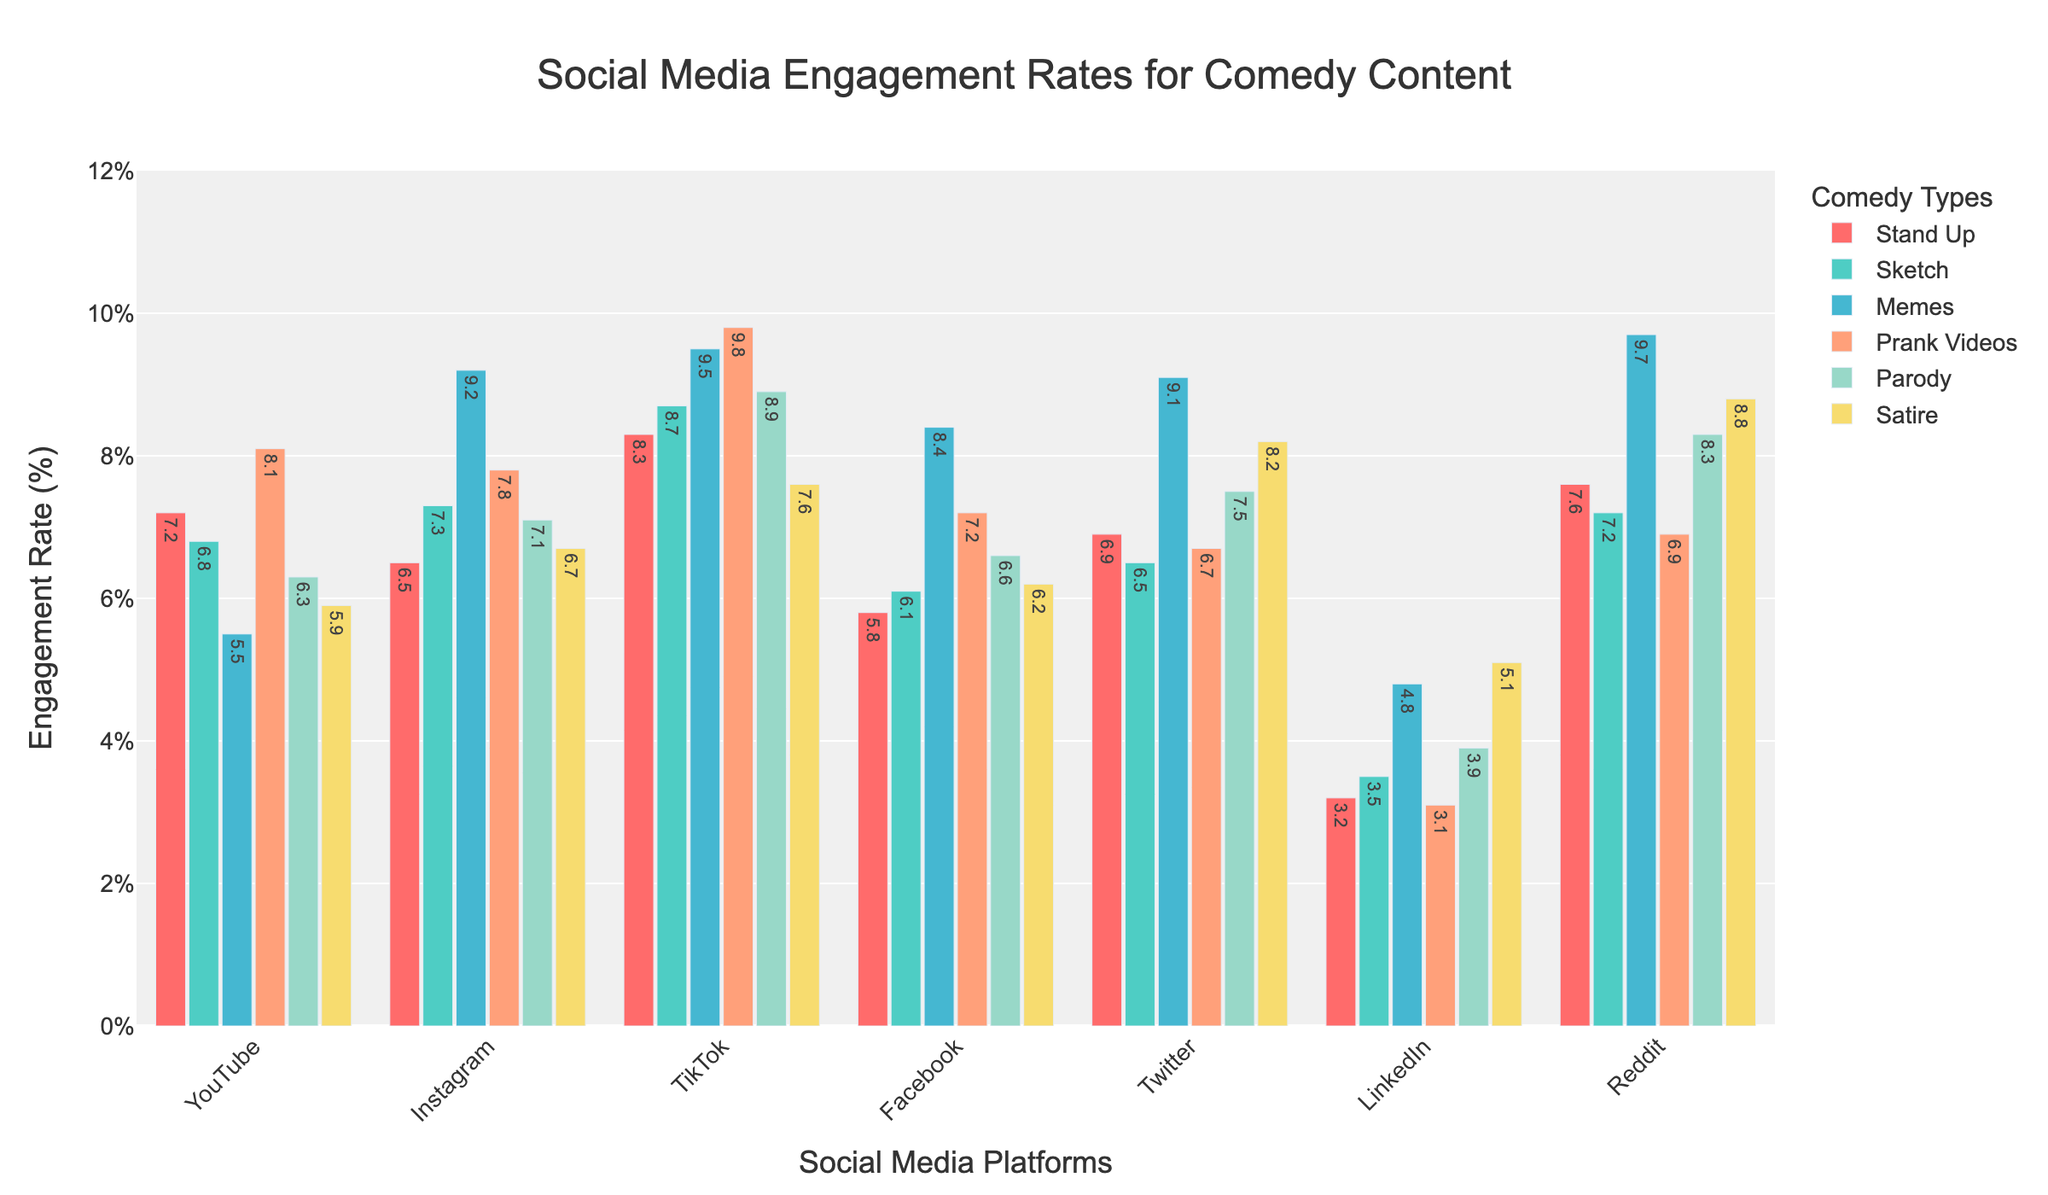Which comedy type has the highest engagement rate on TikTok? Look at the TikTok column and identify the row with the highest value.
Answer: Prank videos How does the engagement rate for memes on Reddit compare to that on Instagram? Find the engagement rates for memes on Reddit and Instagram and compare the values. Reddit has 9.7% and Instagram has 9.2%, so Reddit is higher.
Answer: Reddit is higher What's the total engagement rate for stand-up comedy across all platforms? Add up the engagement rates for stand-up comedy across all the platforms: 7.2 + 6.5 + 8.3 + 5.8 + 6.9 + 3.2 + 7.6.
Answer: 45.5 Which platform shows the lowest engagement rate for parody content? Look at the parody content column and identify the platform with the smallest value.
Answer: LinkedIn What's the difference in engagement rates for satire between YouTube and Facebook? Subtract the engagement rate of satire on Facebook (6.2%) from the value on YouTube (5.9%). 6.2 - 5.9 = 0.3%.
Answer: 0.3% On which platform does sketch comedy outperform stand-up comedy by the greatest margin? For each platform, subtract the engagement rate of stand-up comedy from the engagement rate of sketch comedy and find the maximum difference. This difference is greatest on Instagram (7.3 - 6.5 = 0.8).
Answer: Instagram Which platform has the smallest range in engagement rates between the different comedy types? Calculate the range (max - min) of engagement rates for each platform and find the one with the smallest range. LinkedIn has the smallest range (5.1 - 3.1 = 2.0).
Answer: LinkedIn If you average the engagement rates for stand-up and sketch comedy across all platforms, which platform has the highest combined average rate? Average the engagement rates for stand-up and sketch on each platform and compare. TikTok has the highest combined average ((8.3 + 8.7) / 2 = 8.5).
Answer: TikTok Which type of comedy has the highest average engagement rate across all platforms? Calculate the average engagement rates for each comedy type and identify the highest. Memes have the highest average. (Sum of engagement rates for Memes / 7 platforms)
Answer: Memes How does the engagement of prank videos compare on YouTube and TikTok? Compare the engagement rates for prank videos on YouTube (8.1%) and TikTok (9.8%). TikTok is higher.
Answer: TikTok is higher 